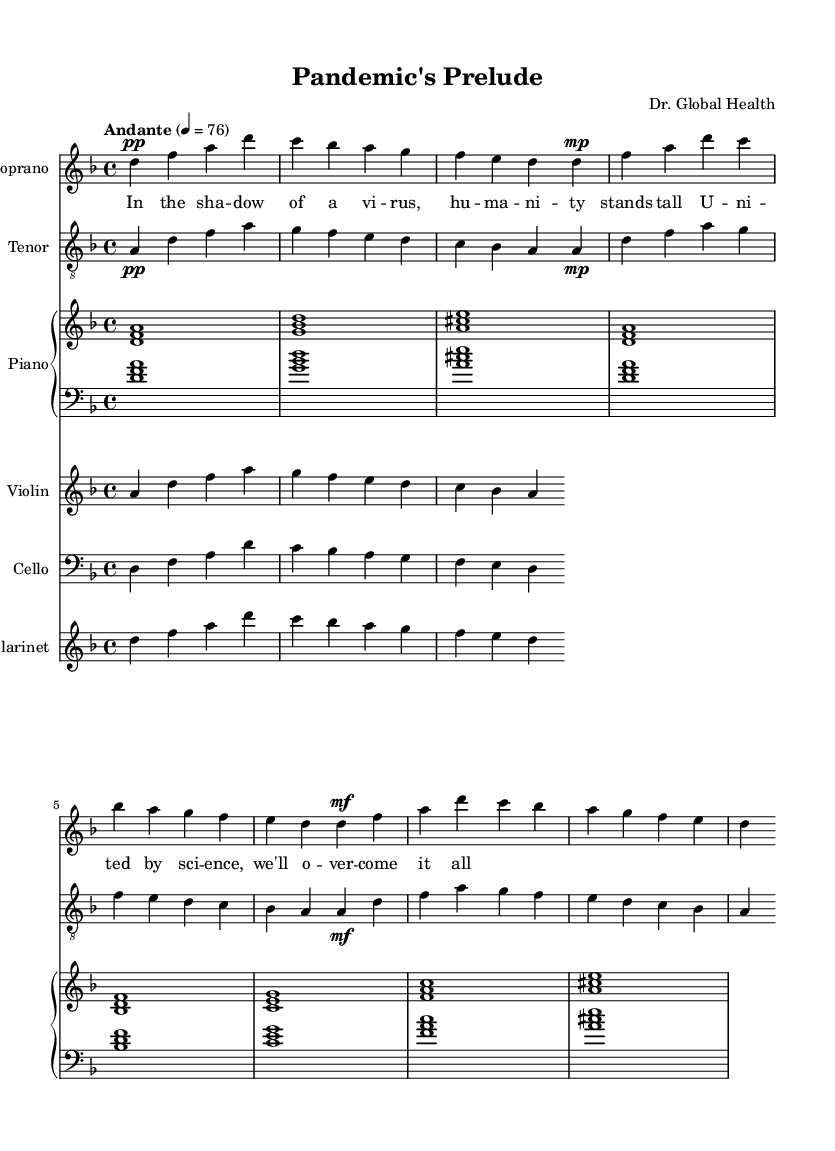What is the key signature of this music? The key signature is indicated at the beginning of the score. In this case, it is D minor, which has one flat (B flat).
Answer: D minor What is the time signature of this music? The time signature is located at the beginning of the score and indicates how many beats are in each measure. Here, it is 4/4, meaning there are four beats per measure.
Answer: 4/4 What is the tempo marking for this piece? The tempo marking is found at the beginning of the score and indicates how fast the piece should be played. It states "Andante," which refers to a moderate walking pace, specifically "4 = 76" meaning 76 beats per minute.
Answer: Andante What instruments are included in this score? The instruments are listed at the beginning of each staff. This piece includes Soprano, Tenor, Piano, Violin, Cello, and Clarinet.
Answer: Soprano, Tenor, Piano, Violin, Cello, Clarinet How does the dynamic marking for the soprano change throughout the piece? The dynamic markings are indicated next to the notes for the Soprano part. It starts with "pp" (pianissimo), then changes to "mp" (mezzo-piano), and ends with "mf" (mezzo-forte), indicating a gradual increase in volume.
Answer: pp, mp, mf What is the main theme expressed in the lyrics of this opera piece? The theme can be deduced by analyzing the lyrics provided under the Soprano part. The lyrics talk about humanity standing tall and overcoming challenges together, emphasizing unity and resilience in the face of a virus.
Answer: Unity and resilience 